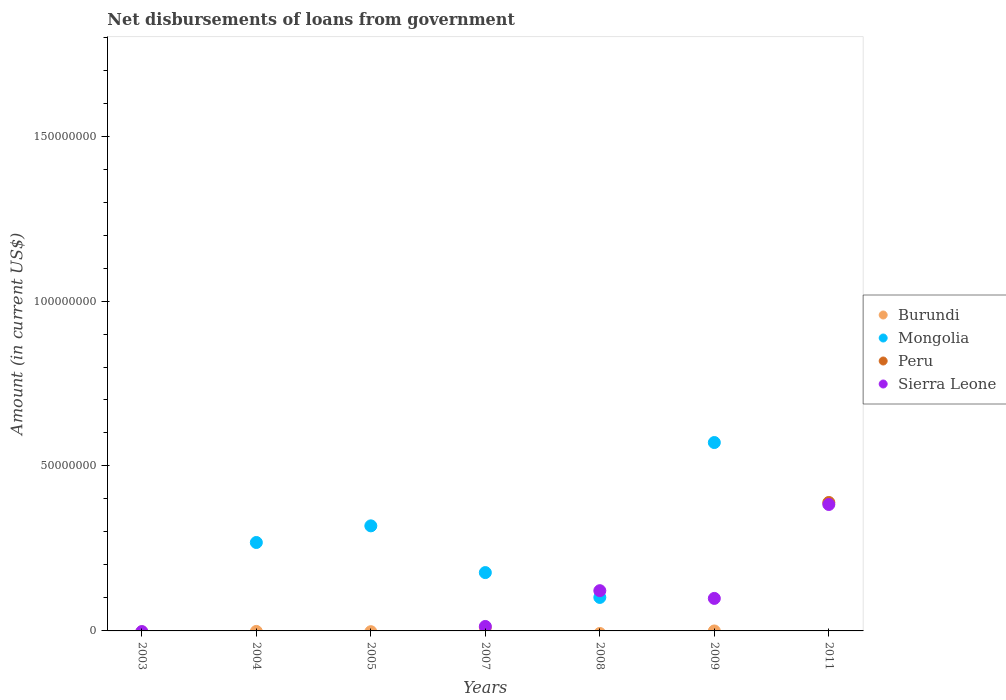Across all years, what is the maximum amount of loan disbursed from government in Burundi?
Ensure brevity in your answer.  9.76e+05. What is the total amount of loan disbursed from government in Sierra Leone in the graph?
Your answer should be compact. 6.17e+07. What is the difference between the amount of loan disbursed from government in Sierra Leone in 2008 and that in 2009?
Ensure brevity in your answer.  2.34e+06. What is the difference between the amount of loan disbursed from government in Mongolia in 2011 and the amount of loan disbursed from government in Burundi in 2009?
Ensure brevity in your answer.  0. What is the average amount of loan disbursed from government in Burundi per year?
Make the answer very short. 1.39e+05. In the year 2007, what is the difference between the amount of loan disbursed from government in Burundi and amount of loan disbursed from government in Mongolia?
Offer a terse response. -1.67e+07. What is the ratio of the amount of loan disbursed from government in Sierra Leone in 2007 to that in 2008?
Keep it short and to the point. 0.11. What is the difference between the highest and the second highest amount of loan disbursed from government in Mongolia?
Provide a succinct answer. 2.53e+07. What is the difference between the highest and the lowest amount of loan disbursed from government in Sierra Leone?
Keep it short and to the point. 3.83e+07. In how many years, is the amount of loan disbursed from government in Sierra Leone greater than the average amount of loan disbursed from government in Sierra Leone taken over all years?
Make the answer very short. 3. Is the sum of the amount of loan disbursed from government in Mongolia in 2007 and 2009 greater than the maximum amount of loan disbursed from government in Peru across all years?
Provide a short and direct response. Yes. Is it the case that in every year, the sum of the amount of loan disbursed from government in Mongolia and amount of loan disbursed from government in Sierra Leone  is greater than the amount of loan disbursed from government in Burundi?
Your response must be concise. No. Does the amount of loan disbursed from government in Mongolia monotonically increase over the years?
Offer a very short reply. No. How many dotlines are there?
Offer a terse response. 4. What is the difference between two consecutive major ticks on the Y-axis?
Ensure brevity in your answer.  5.00e+07. Does the graph contain grids?
Keep it short and to the point. No. Where does the legend appear in the graph?
Offer a terse response. Center right. How many legend labels are there?
Your answer should be compact. 4. What is the title of the graph?
Ensure brevity in your answer.  Net disbursements of loans from government. Does "Kazakhstan" appear as one of the legend labels in the graph?
Make the answer very short. No. What is the label or title of the X-axis?
Ensure brevity in your answer.  Years. What is the Amount (in current US$) of Burundi in 2003?
Your answer should be compact. 0. What is the Amount (in current US$) in Mongolia in 2003?
Your answer should be compact. 0. What is the Amount (in current US$) in Burundi in 2004?
Offer a very short reply. 0. What is the Amount (in current US$) of Mongolia in 2004?
Keep it short and to the point. 2.68e+07. What is the Amount (in current US$) in Burundi in 2005?
Offer a very short reply. 0. What is the Amount (in current US$) of Mongolia in 2005?
Ensure brevity in your answer.  3.18e+07. What is the Amount (in current US$) of Sierra Leone in 2005?
Offer a very short reply. 0. What is the Amount (in current US$) in Burundi in 2007?
Your answer should be compact. 9.76e+05. What is the Amount (in current US$) in Mongolia in 2007?
Offer a terse response. 1.77e+07. What is the Amount (in current US$) of Peru in 2007?
Offer a very short reply. 0. What is the Amount (in current US$) in Sierra Leone in 2007?
Your response must be concise. 1.35e+06. What is the Amount (in current US$) in Burundi in 2008?
Provide a succinct answer. 0. What is the Amount (in current US$) in Mongolia in 2008?
Your answer should be compact. 1.02e+07. What is the Amount (in current US$) in Peru in 2008?
Give a very brief answer. 0. What is the Amount (in current US$) in Sierra Leone in 2008?
Provide a short and direct response. 1.22e+07. What is the Amount (in current US$) in Mongolia in 2009?
Provide a short and direct response. 5.71e+07. What is the Amount (in current US$) of Sierra Leone in 2009?
Keep it short and to the point. 9.86e+06. What is the Amount (in current US$) in Mongolia in 2011?
Provide a succinct answer. 0. What is the Amount (in current US$) of Peru in 2011?
Your response must be concise. 3.89e+07. What is the Amount (in current US$) in Sierra Leone in 2011?
Your answer should be compact. 3.83e+07. Across all years, what is the maximum Amount (in current US$) in Burundi?
Give a very brief answer. 9.76e+05. Across all years, what is the maximum Amount (in current US$) of Mongolia?
Make the answer very short. 5.71e+07. Across all years, what is the maximum Amount (in current US$) of Peru?
Your answer should be compact. 3.89e+07. Across all years, what is the maximum Amount (in current US$) in Sierra Leone?
Keep it short and to the point. 3.83e+07. Across all years, what is the minimum Amount (in current US$) in Peru?
Offer a terse response. 0. What is the total Amount (in current US$) of Burundi in the graph?
Offer a terse response. 9.76e+05. What is the total Amount (in current US$) of Mongolia in the graph?
Offer a terse response. 1.44e+08. What is the total Amount (in current US$) of Peru in the graph?
Your answer should be compact. 3.89e+07. What is the total Amount (in current US$) in Sierra Leone in the graph?
Give a very brief answer. 6.17e+07. What is the difference between the Amount (in current US$) of Mongolia in 2004 and that in 2005?
Your answer should be very brief. -5.04e+06. What is the difference between the Amount (in current US$) of Mongolia in 2004 and that in 2007?
Keep it short and to the point. 9.12e+06. What is the difference between the Amount (in current US$) of Mongolia in 2004 and that in 2008?
Your response must be concise. 1.67e+07. What is the difference between the Amount (in current US$) of Mongolia in 2004 and that in 2009?
Offer a terse response. -3.03e+07. What is the difference between the Amount (in current US$) of Mongolia in 2005 and that in 2007?
Ensure brevity in your answer.  1.42e+07. What is the difference between the Amount (in current US$) of Mongolia in 2005 and that in 2008?
Give a very brief answer. 2.17e+07. What is the difference between the Amount (in current US$) of Mongolia in 2005 and that in 2009?
Make the answer very short. -2.53e+07. What is the difference between the Amount (in current US$) in Mongolia in 2007 and that in 2008?
Your response must be concise. 7.53e+06. What is the difference between the Amount (in current US$) in Sierra Leone in 2007 and that in 2008?
Your response must be concise. -1.08e+07. What is the difference between the Amount (in current US$) in Mongolia in 2007 and that in 2009?
Give a very brief answer. -3.94e+07. What is the difference between the Amount (in current US$) of Sierra Leone in 2007 and that in 2009?
Make the answer very short. -8.50e+06. What is the difference between the Amount (in current US$) in Sierra Leone in 2007 and that in 2011?
Your answer should be very brief. -3.70e+07. What is the difference between the Amount (in current US$) in Mongolia in 2008 and that in 2009?
Provide a short and direct response. -4.70e+07. What is the difference between the Amount (in current US$) of Sierra Leone in 2008 and that in 2009?
Keep it short and to the point. 2.34e+06. What is the difference between the Amount (in current US$) of Sierra Leone in 2008 and that in 2011?
Your response must be concise. -2.61e+07. What is the difference between the Amount (in current US$) of Sierra Leone in 2009 and that in 2011?
Provide a succinct answer. -2.85e+07. What is the difference between the Amount (in current US$) in Mongolia in 2004 and the Amount (in current US$) in Sierra Leone in 2007?
Your response must be concise. 2.55e+07. What is the difference between the Amount (in current US$) of Mongolia in 2004 and the Amount (in current US$) of Sierra Leone in 2008?
Make the answer very short. 1.46e+07. What is the difference between the Amount (in current US$) of Mongolia in 2004 and the Amount (in current US$) of Sierra Leone in 2009?
Your answer should be very brief. 1.69e+07. What is the difference between the Amount (in current US$) of Mongolia in 2004 and the Amount (in current US$) of Peru in 2011?
Offer a terse response. -1.21e+07. What is the difference between the Amount (in current US$) of Mongolia in 2004 and the Amount (in current US$) of Sierra Leone in 2011?
Offer a terse response. -1.15e+07. What is the difference between the Amount (in current US$) of Mongolia in 2005 and the Amount (in current US$) of Sierra Leone in 2007?
Your answer should be compact. 3.05e+07. What is the difference between the Amount (in current US$) in Mongolia in 2005 and the Amount (in current US$) in Sierra Leone in 2008?
Make the answer very short. 1.96e+07. What is the difference between the Amount (in current US$) of Mongolia in 2005 and the Amount (in current US$) of Sierra Leone in 2009?
Your response must be concise. 2.20e+07. What is the difference between the Amount (in current US$) of Mongolia in 2005 and the Amount (in current US$) of Peru in 2011?
Make the answer very short. -7.09e+06. What is the difference between the Amount (in current US$) in Mongolia in 2005 and the Amount (in current US$) in Sierra Leone in 2011?
Give a very brief answer. -6.48e+06. What is the difference between the Amount (in current US$) of Burundi in 2007 and the Amount (in current US$) of Mongolia in 2008?
Your response must be concise. -9.18e+06. What is the difference between the Amount (in current US$) in Burundi in 2007 and the Amount (in current US$) in Sierra Leone in 2008?
Ensure brevity in your answer.  -1.12e+07. What is the difference between the Amount (in current US$) in Mongolia in 2007 and the Amount (in current US$) in Sierra Leone in 2008?
Your answer should be compact. 5.48e+06. What is the difference between the Amount (in current US$) in Burundi in 2007 and the Amount (in current US$) in Mongolia in 2009?
Your response must be concise. -5.61e+07. What is the difference between the Amount (in current US$) of Burundi in 2007 and the Amount (in current US$) of Sierra Leone in 2009?
Offer a terse response. -8.88e+06. What is the difference between the Amount (in current US$) of Mongolia in 2007 and the Amount (in current US$) of Sierra Leone in 2009?
Your answer should be very brief. 7.83e+06. What is the difference between the Amount (in current US$) in Burundi in 2007 and the Amount (in current US$) in Peru in 2011?
Your response must be concise. -3.80e+07. What is the difference between the Amount (in current US$) in Burundi in 2007 and the Amount (in current US$) in Sierra Leone in 2011?
Your answer should be very brief. -3.73e+07. What is the difference between the Amount (in current US$) in Mongolia in 2007 and the Amount (in current US$) in Peru in 2011?
Make the answer very short. -2.13e+07. What is the difference between the Amount (in current US$) of Mongolia in 2007 and the Amount (in current US$) of Sierra Leone in 2011?
Keep it short and to the point. -2.06e+07. What is the difference between the Amount (in current US$) of Mongolia in 2008 and the Amount (in current US$) of Sierra Leone in 2009?
Your response must be concise. 2.97e+05. What is the difference between the Amount (in current US$) in Mongolia in 2008 and the Amount (in current US$) in Peru in 2011?
Provide a short and direct response. -2.88e+07. What is the difference between the Amount (in current US$) in Mongolia in 2008 and the Amount (in current US$) in Sierra Leone in 2011?
Provide a succinct answer. -2.82e+07. What is the difference between the Amount (in current US$) in Mongolia in 2009 and the Amount (in current US$) in Peru in 2011?
Ensure brevity in your answer.  1.82e+07. What is the difference between the Amount (in current US$) of Mongolia in 2009 and the Amount (in current US$) of Sierra Leone in 2011?
Provide a short and direct response. 1.88e+07. What is the average Amount (in current US$) in Burundi per year?
Offer a very short reply. 1.39e+05. What is the average Amount (in current US$) of Mongolia per year?
Provide a succinct answer. 2.05e+07. What is the average Amount (in current US$) in Peru per year?
Your response must be concise. 5.56e+06. What is the average Amount (in current US$) in Sierra Leone per year?
Offer a very short reply. 8.82e+06. In the year 2007, what is the difference between the Amount (in current US$) in Burundi and Amount (in current US$) in Mongolia?
Your answer should be very brief. -1.67e+07. In the year 2007, what is the difference between the Amount (in current US$) of Burundi and Amount (in current US$) of Sierra Leone?
Your response must be concise. -3.78e+05. In the year 2007, what is the difference between the Amount (in current US$) of Mongolia and Amount (in current US$) of Sierra Leone?
Offer a very short reply. 1.63e+07. In the year 2008, what is the difference between the Amount (in current US$) of Mongolia and Amount (in current US$) of Sierra Leone?
Offer a terse response. -2.05e+06. In the year 2009, what is the difference between the Amount (in current US$) of Mongolia and Amount (in current US$) of Sierra Leone?
Give a very brief answer. 4.72e+07. In the year 2011, what is the difference between the Amount (in current US$) of Peru and Amount (in current US$) of Sierra Leone?
Offer a very short reply. 6.09e+05. What is the ratio of the Amount (in current US$) in Mongolia in 2004 to that in 2005?
Give a very brief answer. 0.84. What is the ratio of the Amount (in current US$) of Mongolia in 2004 to that in 2007?
Your answer should be compact. 1.52. What is the ratio of the Amount (in current US$) in Mongolia in 2004 to that in 2008?
Your answer should be compact. 2.64. What is the ratio of the Amount (in current US$) in Mongolia in 2004 to that in 2009?
Provide a short and direct response. 0.47. What is the ratio of the Amount (in current US$) of Mongolia in 2005 to that in 2007?
Give a very brief answer. 1.8. What is the ratio of the Amount (in current US$) in Mongolia in 2005 to that in 2008?
Provide a short and direct response. 3.14. What is the ratio of the Amount (in current US$) in Mongolia in 2005 to that in 2009?
Make the answer very short. 0.56. What is the ratio of the Amount (in current US$) of Mongolia in 2007 to that in 2008?
Make the answer very short. 1.74. What is the ratio of the Amount (in current US$) of Sierra Leone in 2007 to that in 2008?
Your response must be concise. 0.11. What is the ratio of the Amount (in current US$) in Mongolia in 2007 to that in 2009?
Provide a succinct answer. 0.31. What is the ratio of the Amount (in current US$) of Sierra Leone in 2007 to that in 2009?
Your answer should be compact. 0.14. What is the ratio of the Amount (in current US$) in Sierra Leone in 2007 to that in 2011?
Offer a very short reply. 0.04. What is the ratio of the Amount (in current US$) in Mongolia in 2008 to that in 2009?
Your response must be concise. 0.18. What is the ratio of the Amount (in current US$) in Sierra Leone in 2008 to that in 2009?
Keep it short and to the point. 1.24. What is the ratio of the Amount (in current US$) in Sierra Leone in 2008 to that in 2011?
Give a very brief answer. 0.32. What is the ratio of the Amount (in current US$) of Sierra Leone in 2009 to that in 2011?
Your answer should be very brief. 0.26. What is the difference between the highest and the second highest Amount (in current US$) of Mongolia?
Your answer should be compact. 2.53e+07. What is the difference between the highest and the second highest Amount (in current US$) of Sierra Leone?
Your answer should be compact. 2.61e+07. What is the difference between the highest and the lowest Amount (in current US$) of Burundi?
Your answer should be very brief. 9.76e+05. What is the difference between the highest and the lowest Amount (in current US$) in Mongolia?
Provide a short and direct response. 5.71e+07. What is the difference between the highest and the lowest Amount (in current US$) in Peru?
Provide a succinct answer. 3.89e+07. What is the difference between the highest and the lowest Amount (in current US$) in Sierra Leone?
Offer a very short reply. 3.83e+07. 